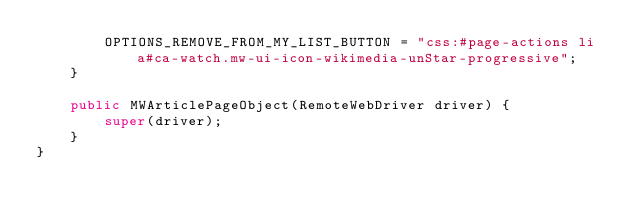Convert code to text. <code><loc_0><loc_0><loc_500><loc_500><_Java_>        OPTIONS_REMOVE_FROM_MY_LIST_BUTTON = "css:#page-actions li a#ca-watch.mw-ui-icon-wikimedia-unStar-progressive";
    }

    public MWArticlePageObject(RemoteWebDriver driver) {
        super(driver);
    }
}
</code> 